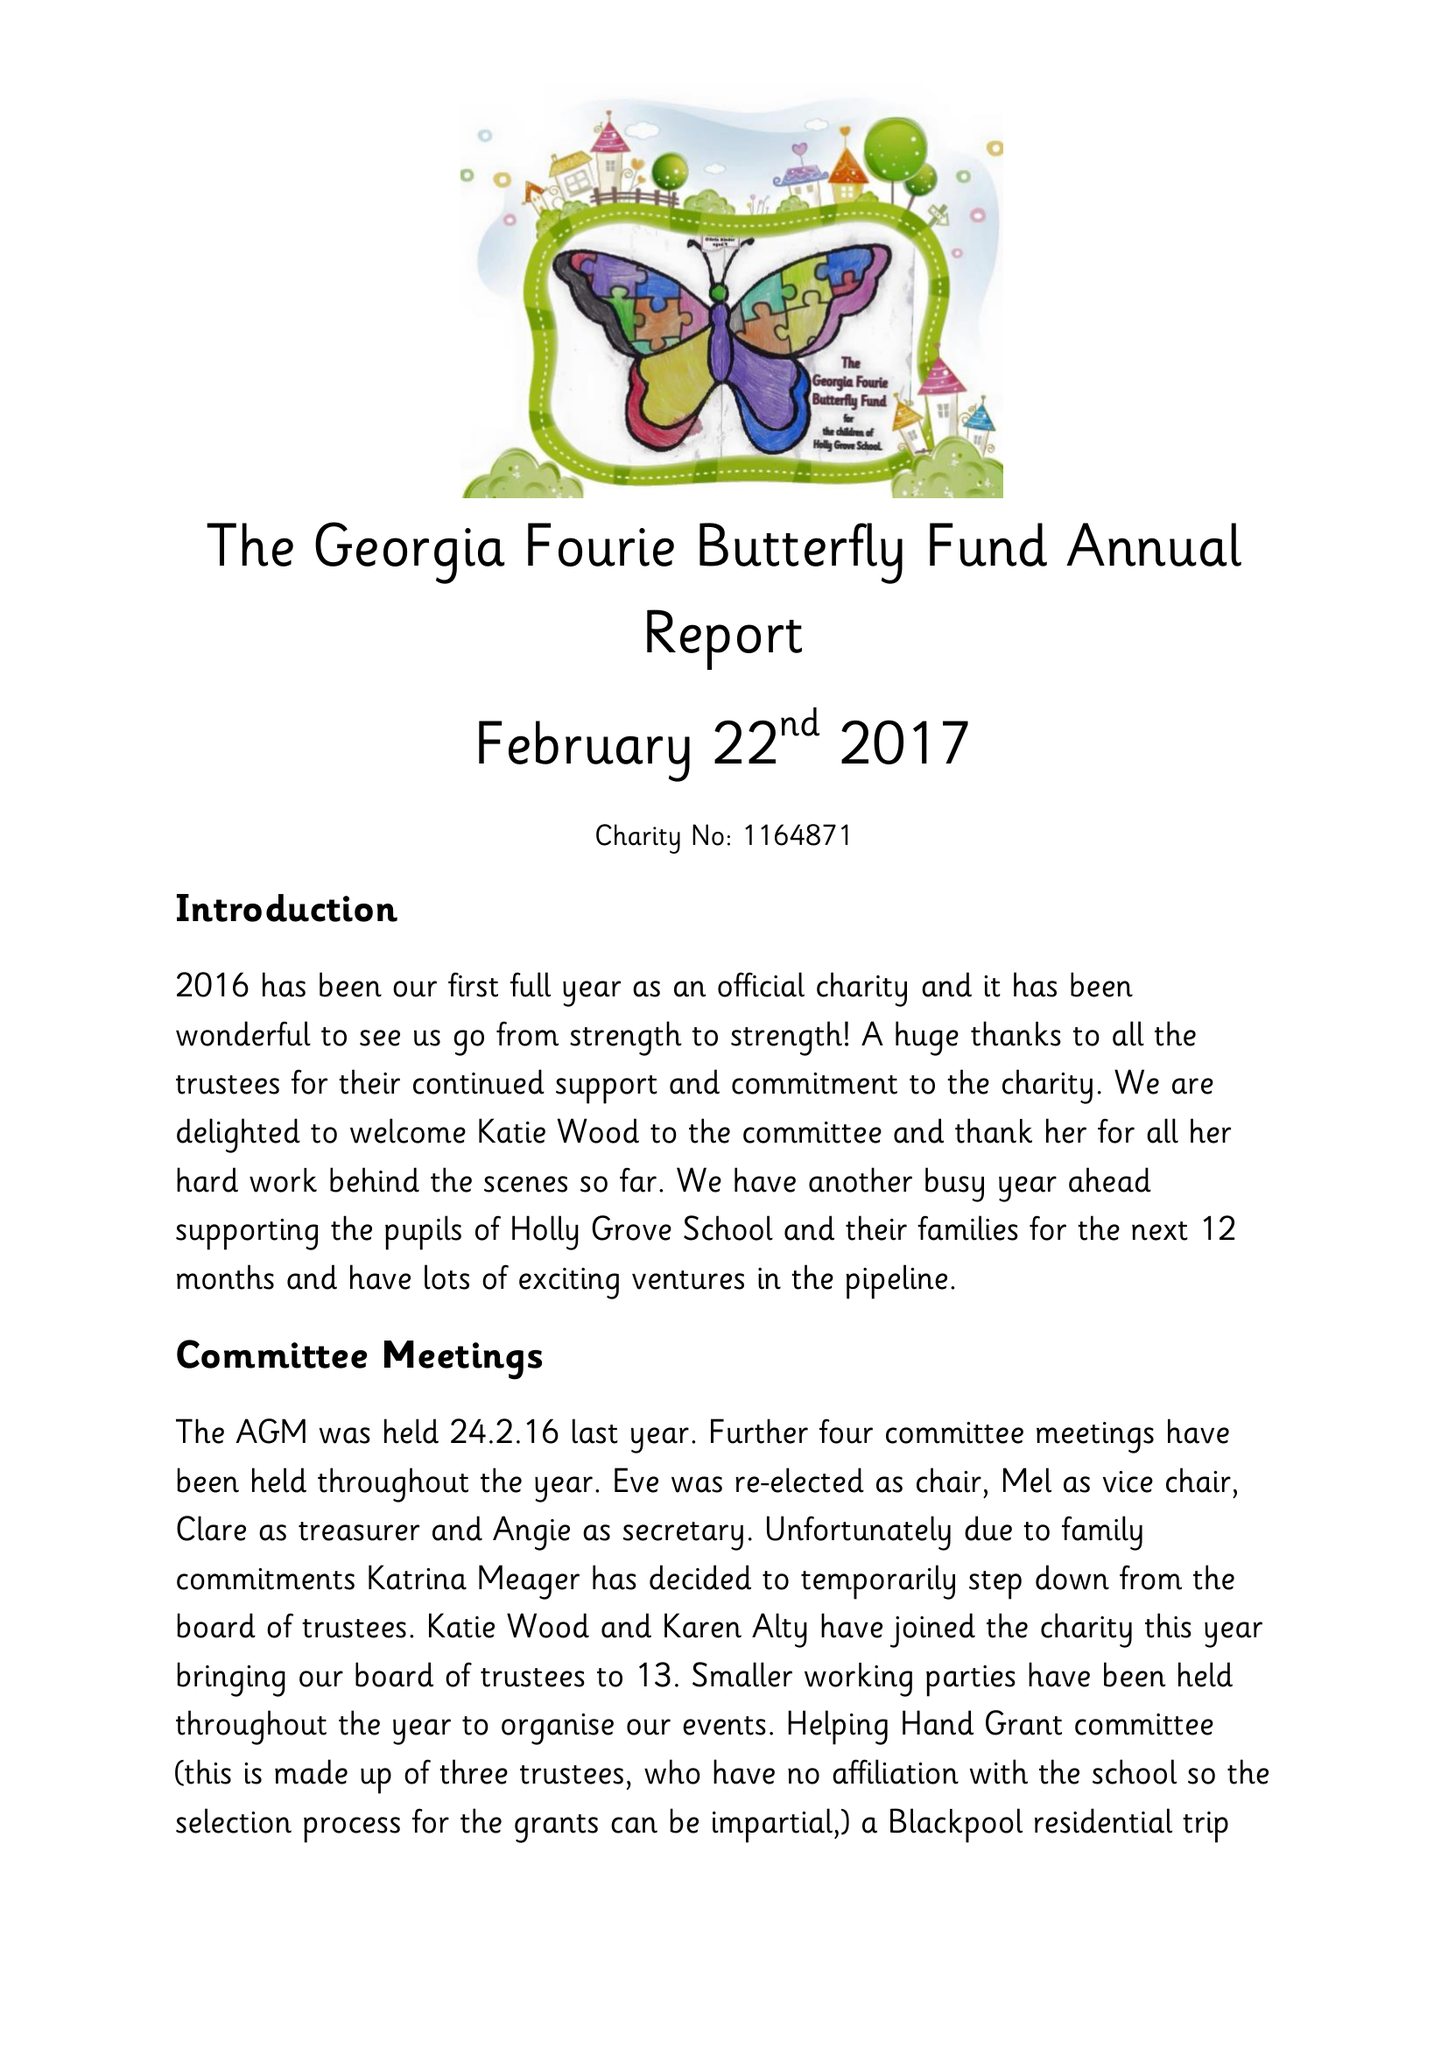What is the value for the income_annually_in_british_pounds?
Answer the question using a single word or phrase. 26509.00 